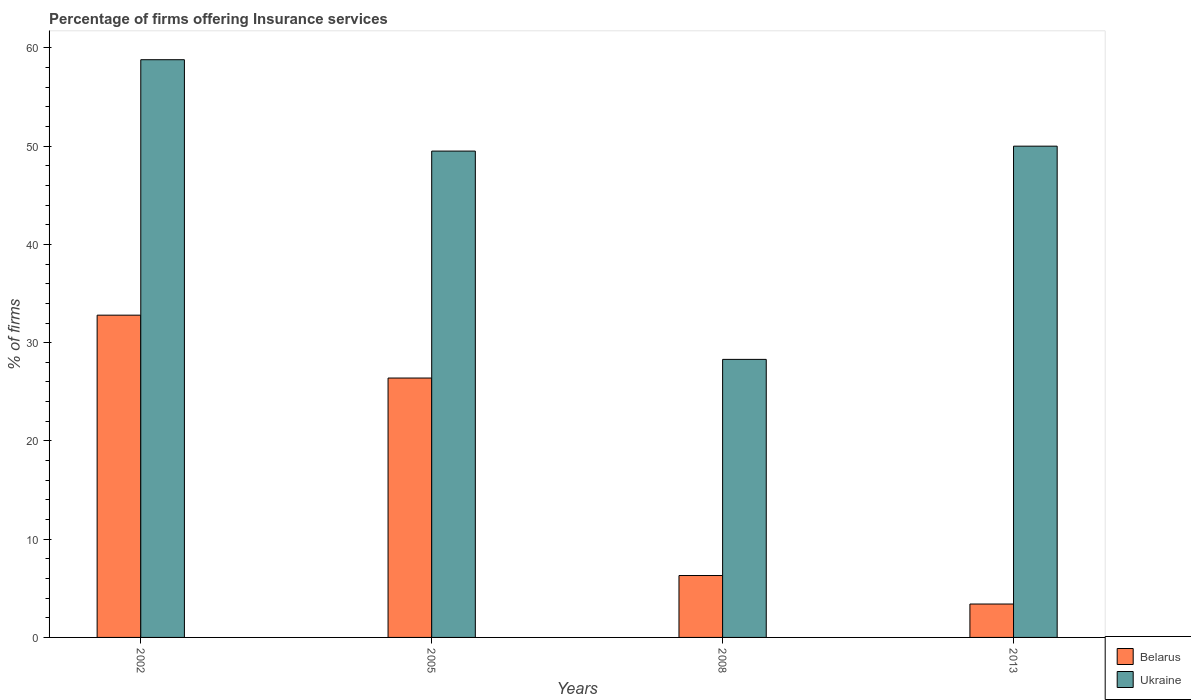How many different coloured bars are there?
Your response must be concise. 2. How many groups of bars are there?
Provide a short and direct response. 4. Are the number of bars per tick equal to the number of legend labels?
Ensure brevity in your answer.  Yes. Are the number of bars on each tick of the X-axis equal?
Keep it short and to the point. Yes. How many bars are there on the 2nd tick from the right?
Make the answer very short. 2. What is the label of the 2nd group of bars from the left?
Provide a succinct answer. 2005. What is the percentage of firms offering insurance services in Belarus in 2013?
Provide a succinct answer. 3.4. Across all years, what is the maximum percentage of firms offering insurance services in Belarus?
Provide a succinct answer. 32.8. Across all years, what is the minimum percentage of firms offering insurance services in Ukraine?
Give a very brief answer. 28.3. What is the total percentage of firms offering insurance services in Belarus in the graph?
Provide a short and direct response. 68.9. What is the difference between the percentage of firms offering insurance services in Ukraine in 2002 and that in 2013?
Make the answer very short. 8.8. What is the difference between the percentage of firms offering insurance services in Belarus in 2008 and the percentage of firms offering insurance services in Ukraine in 2002?
Your answer should be very brief. -52.5. What is the average percentage of firms offering insurance services in Ukraine per year?
Keep it short and to the point. 46.65. In how many years, is the percentage of firms offering insurance services in Ukraine greater than 44 %?
Make the answer very short. 3. What is the ratio of the percentage of firms offering insurance services in Ukraine in 2002 to that in 2013?
Ensure brevity in your answer.  1.18. Is the percentage of firms offering insurance services in Belarus in 2002 less than that in 2013?
Give a very brief answer. No. What is the difference between the highest and the second highest percentage of firms offering insurance services in Ukraine?
Ensure brevity in your answer.  8.8. What is the difference between the highest and the lowest percentage of firms offering insurance services in Ukraine?
Offer a very short reply. 30.5. In how many years, is the percentage of firms offering insurance services in Belarus greater than the average percentage of firms offering insurance services in Belarus taken over all years?
Provide a succinct answer. 2. Is the sum of the percentage of firms offering insurance services in Ukraine in 2005 and 2013 greater than the maximum percentage of firms offering insurance services in Belarus across all years?
Offer a very short reply. Yes. What does the 2nd bar from the left in 2002 represents?
Your answer should be very brief. Ukraine. What does the 2nd bar from the right in 2008 represents?
Give a very brief answer. Belarus. Are all the bars in the graph horizontal?
Provide a succinct answer. No. Does the graph contain grids?
Give a very brief answer. No. Where does the legend appear in the graph?
Your answer should be compact. Bottom right. How many legend labels are there?
Offer a very short reply. 2. What is the title of the graph?
Provide a succinct answer. Percentage of firms offering Insurance services. What is the label or title of the Y-axis?
Your answer should be very brief. % of firms. What is the % of firms in Belarus in 2002?
Provide a succinct answer. 32.8. What is the % of firms of Ukraine in 2002?
Your answer should be very brief. 58.8. What is the % of firms of Belarus in 2005?
Offer a very short reply. 26.4. What is the % of firms in Ukraine in 2005?
Provide a succinct answer. 49.5. What is the % of firms of Belarus in 2008?
Ensure brevity in your answer.  6.3. What is the % of firms in Ukraine in 2008?
Provide a short and direct response. 28.3. What is the % of firms of Belarus in 2013?
Your response must be concise. 3.4. What is the % of firms in Ukraine in 2013?
Give a very brief answer. 50. Across all years, what is the maximum % of firms in Belarus?
Offer a terse response. 32.8. Across all years, what is the maximum % of firms in Ukraine?
Your answer should be very brief. 58.8. Across all years, what is the minimum % of firms of Ukraine?
Your answer should be very brief. 28.3. What is the total % of firms of Belarus in the graph?
Offer a very short reply. 68.9. What is the total % of firms of Ukraine in the graph?
Offer a very short reply. 186.6. What is the difference between the % of firms in Belarus in 2002 and that in 2005?
Keep it short and to the point. 6.4. What is the difference between the % of firms in Ukraine in 2002 and that in 2008?
Ensure brevity in your answer.  30.5. What is the difference between the % of firms of Belarus in 2002 and that in 2013?
Provide a short and direct response. 29.4. What is the difference between the % of firms in Ukraine in 2002 and that in 2013?
Ensure brevity in your answer.  8.8. What is the difference between the % of firms of Belarus in 2005 and that in 2008?
Offer a very short reply. 20.1. What is the difference between the % of firms of Ukraine in 2005 and that in 2008?
Make the answer very short. 21.2. What is the difference between the % of firms in Belarus in 2005 and that in 2013?
Offer a terse response. 23. What is the difference between the % of firms of Ukraine in 2008 and that in 2013?
Your answer should be compact. -21.7. What is the difference between the % of firms in Belarus in 2002 and the % of firms in Ukraine in 2005?
Your response must be concise. -16.7. What is the difference between the % of firms of Belarus in 2002 and the % of firms of Ukraine in 2008?
Your answer should be compact. 4.5. What is the difference between the % of firms in Belarus in 2002 and the % of firms in Ukraine in 2013?
Your answer should be compact. -17.2. What is the difference between the % of firms of Belarus in 2005 and the % of firms of Ukraine in 2013?
Your response must be concise. -23.6. What is the difference between the % of firms of Belarus in 2008 and the % of firms of Ukraine in 2013?
Ensure brevity in your answer.  -43.7. What is the average % of firms of Belarus per year?
Your answer should be very brief. 17.23. What is the average % of firms of Ukraine per year?
Ensure brevity in your answer.  46.65. In the year 2002, what is the difference between the % of firms of Belarus and % of firms of Ukraine?
Make the answer very short. -26. In the year 2005, what is the difference between the % of firms of Belarus and % of firms of Ukraine?
Your answer should be very brief. -23.1. In the year 2013, what is the difference between the % of firms in Belarus and % of firms in Ukraine?
Provide a short and direct response. -46.6. What is the ratio of the % of firms of Belarus in 2002 to that in 2005?
Make the answer very short. 1.24. What is the ratio of the % of firms in Ukraine in 2002 to that in 2005?
Give a very brief answer. 1.19. What is the ratio of the % of firms in Belarus in 2002 to that in 2008?
Give a very brief answer. 5.21. What is the ratio of the % of firms in Ukraine in 2002 to that in 2008?
Ensure brevity in your answer.  2.08. What is the ratio of the % of firms in Belarus in 2002 to that in 2013?
Ensure brevity in your answer.  9.65. What is the ratio of the % of firms of Ukraine in 2002 to that in 2013?
Keep it short and to the point. 1.18. What is the ratio of the % of firms of Belarus in 2005 to that in 2008?
Your response must be concise. 4.19. What is the ratio of the % of firms of Ukraine in 2005 to that in 2008?
Your answer should be very brief. 1.75. What is the ratio of the % of firms of Belarus in 2005 to that in 2013?
Keep it short and to the point. 7.76. What is the ratio of the % of firms of Ukraine in 2005 to that in 2013?
Offer a very short reply. 0.99. What is the ratio of the % of firms in Belarus in 2008 to that in 2013?
Your answer should be very brief. 1.85. What is the ratio of the % of firms in Ukraine in 2008 to that in 2013?
Provide a short and direct response. 0.57. What is the difference between the highest and the second highest % of firms of Belarus?
Offer a very short reply. 6.4. What is the difference between the highest and the lowest % of firms in Belarus?
Offer a terse response. 29.4. What is the difference between the highest and the lowest % of firms of Ukraine?
Provide a short and direct response. 30.5. 